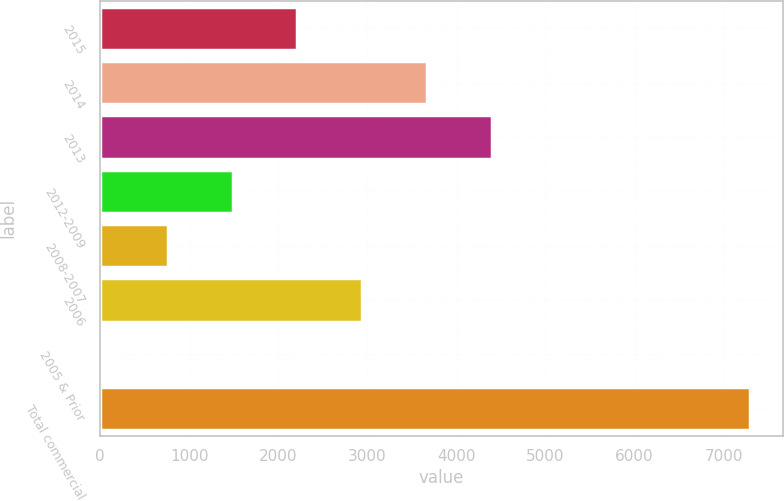Convert chart to OTSL. <chart><loc_0><loc_0><loc_500><loc_500><bar_chart><fcel>2015<fcel>2014<fcel>2013<fcel>2012-2009<fcel>2008-2007<fcel>2006<fcel>2005 & Prior<fcel>Total commercial<nl><fcel>2213.8<fcel>3667<fcel>4393.6<fcel>1487.2<fcel>760.6<fcel>2940.4<fcel>34<fcel>7300<nl></chart> 